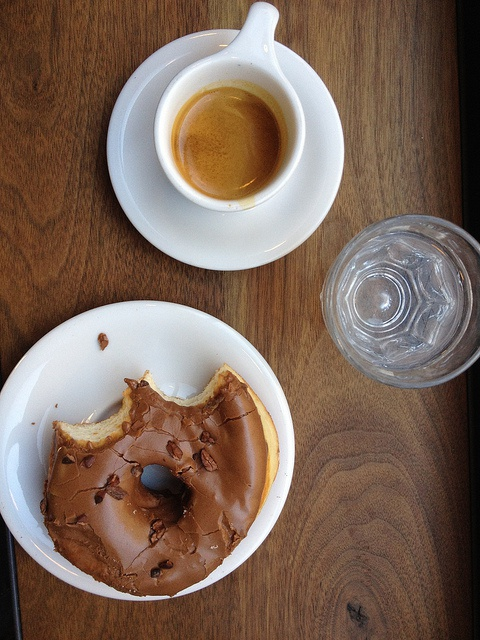Describe the objects in this image and their specific colors. I can see dining table in maroon, brown, lightgray, and gray tones, donut in maroon, gray, and brown tones, cup in maroon, lightgray, olive, and darkgray tones, and cup in maroon, darkgray, and gray tones in this image. 